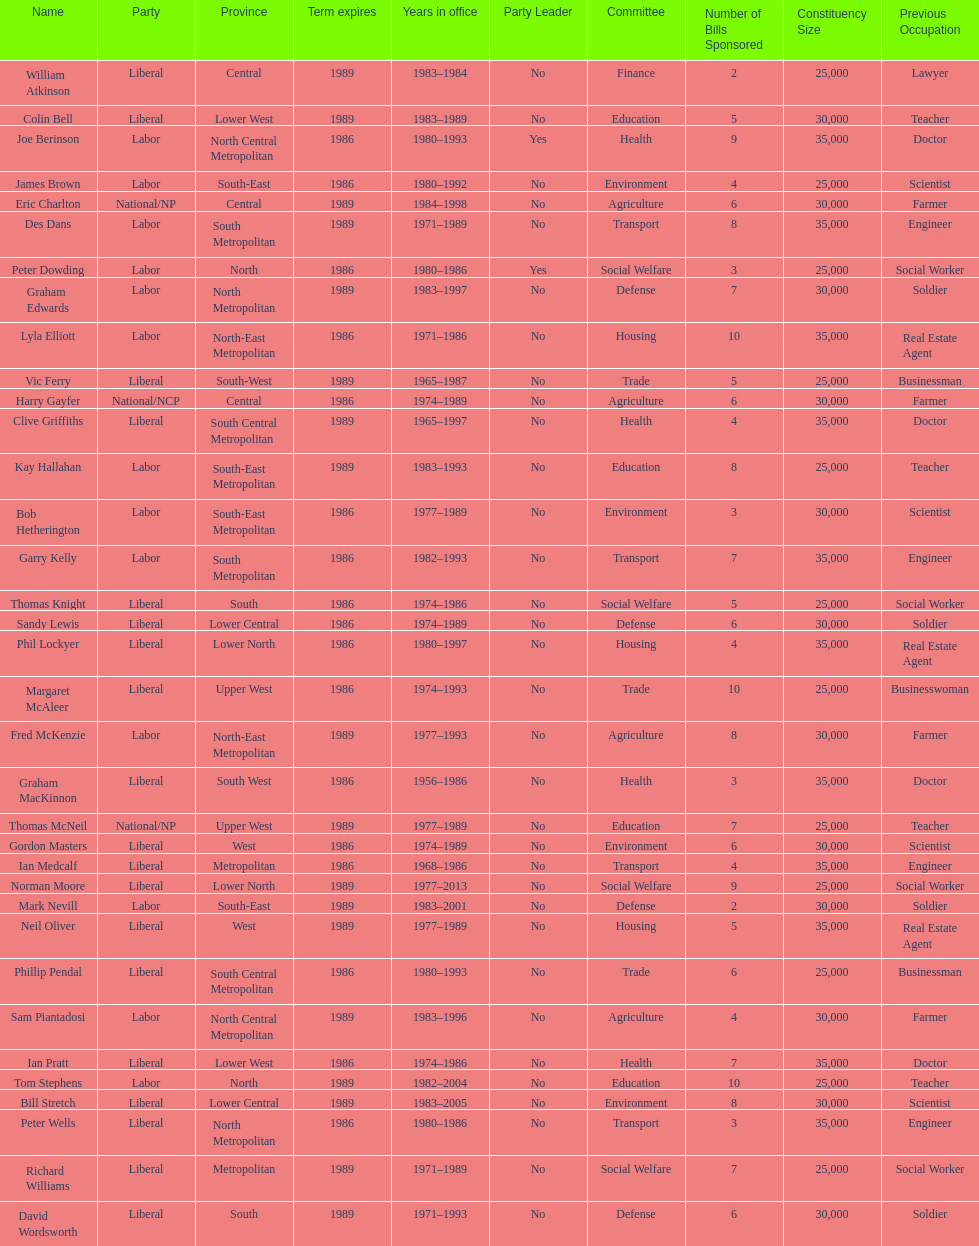Hame the last member listed whose last name begins with "p". Ian Pratt. 